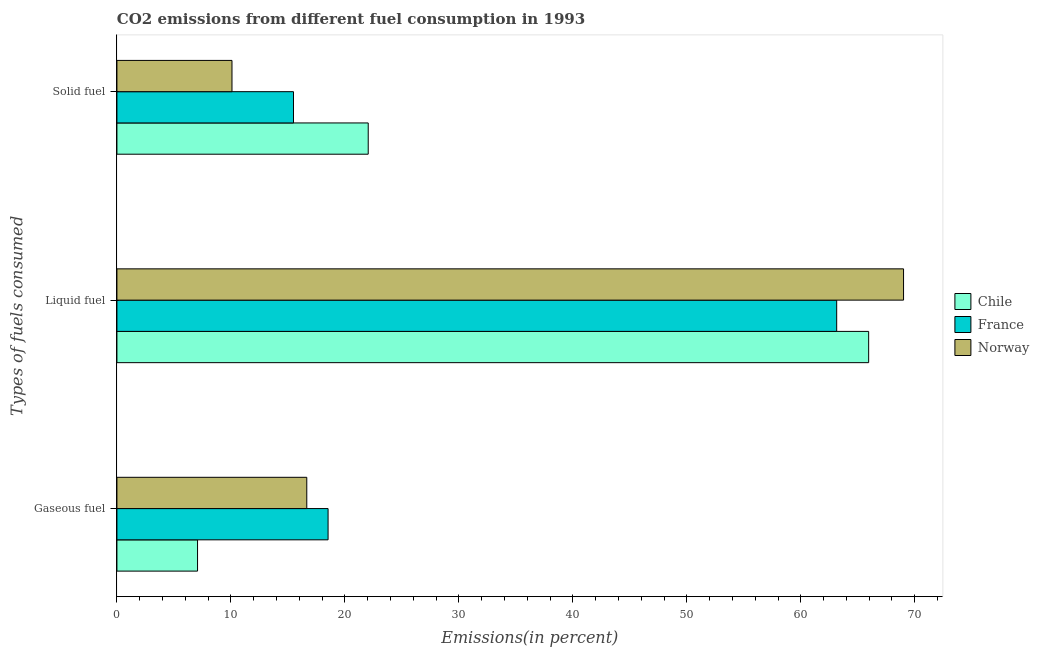Are the number of bars per tick equal to the number of legend labels?
Make the answer very short. Yes. How many bars are there on the 1st tick from the top?
Your answer should be compact. 3. How many bars are there on the 2nd tick from the bottom?
Your answer should be very brief. 3. What is the label of the 2nd group of bars from the top?
Ensure brevity in your answer.  Liquid fuel. What is the percentage of solid fuel emission in Chile?
Keep it short and to the point. 22.05. Across all countries, what is the maximum percentage of gaseous fuel emission?
Your response must be concise. 18.53. Across all countries, what is the minimum percentage of solid fuel emission?
Offer a terse response. 10.1. In which country was the percentage of solid fuel emission minimum?
Provide a succinct answer. Norway. What is the total percentage of solid fuel emission in the graph?
Your answer should be very brief. 47.63. What is the difference between the percentage of liquid fuel emission in Norway and that in Chile?
Provide a succinct answer. 3.06. What is the difference between the percentage of gaseous fuel emission in France and the percentage of solid fuel emission in Chile?
Your answer should be very brief. -3.52. What is the average percentage of liquid fuel emission per country?
Your answer should be compact. 66.04. What is the difference between the percentage of liquid fuel emission and percentage of gaseous fuel emission in France?
Ensure brevity in your answer.  44.62. What is the ratio of the percentage of liquid fuel emission in France to that in Norway?
Keep it short and to the point. 0.92. What is the difference between the highest and the second highest percentage of liquid fuel emission?
Offer a terse response. 3.06. What is the difference between the highest and the lowest percentage of gaseous fuel emission?
Your answer should be compact. 11.45. In how many countries, is the percentage of solid fuel emission greater than the average percentage of solid fuel emission taken over all countries?
Provide a short and direct response. 1. What does the 3rd bar from the top in Solid fuel represents?
Make the answer very short. Chile. How many bars are there?
Your answer should be very brief. 9. Does the graph contain any zero values?
Keep it short and to the point. No. Where does the legend appear in the graph?
Your answer should be very brief. Center right. How many legend labels are there?
Offer a very short reply. 3. What is the title of the graph?
Ensure brevity in your answer.  CO2 emissions from different fuel consumption in 1993. Does "Macao" appear as one of the legend labels in the graph?
Give a very brief answer. No. What is the label or title of the X-axis?
Your response must be concise. Emissions(in percent). What is the label or title of the Y-axis?
Your answer should be very brief. Types of fuels consumed. What is the Emissions(in percent) of Chile in Gaseous fuel?
Your response must be concise. 7.07. What is the Emissions(in percent) of France in Gaseous fuel?
Provide a short and direct response. 18.53. What is the Emissions(in percent) of Norway in Gaseous fuel?
Ensure brevity in your answer.  16.66. What is the Emissions(in percent) of Chile in Liquid fuel?
Keep it short and to the point. 65.95. What is the Emissions(in percent) in France in Liquid fuel?
Ensure brevity in your answer.  63.15. What is the Emissions(in percent) in Norway in Liquid fuel?
Offer a terse response. 69.01. What is the Emissions(in percent) in Chile in Solid fuel?
Ensure brevity in your answer.  22.05. What is the Emissions(in percent) in France in Solid fuel?
Provide a short and direct response. 15.49. What is the Emissions(in percent) in Norway in Solid fuel?
Provide a succinct answer. 10.1. Across all Types of fuels consumed, what is the maximum Emissions(in percent) in Chile?
Give a very brief answer. 65.95. Across all Types of fuels consumed, what is the maximum Emissions(in percent) in France?
Provide a short and direct response. 63.15. Across all Types of fuels consumed, what is the maximum Emissions(in percent) of Norway?
Give a very brief answer. 69.01. Across all Types of fuels consumed, what is the minimum Emissions(in percent) of Chile?
Offer a very short reply. 7.07. Across all Types of fuels consumed, what is the minimum Emissions(in percent) of France?
Make the answer very short. 15.49. Across all Types of fuels consumed, what is the minimum Emissions(in percent) of Norway?
Offer a terse response. 10.1. What is the total Emissions(in percent) of Chile in the graph?
Offer a terse response. 95.08. What is the total Emissions(in percent) of France in the graph?
Ensure brevity in your answer.  97.17. What is the total Emissions(in percent) of Norway in the graph?
Give a very brief answer. 95.77. What is the difference between the Emissions(in percent) of Chile in Gaseous fuel and that in Liquid fuel?
Provide a succinct answer. -58.88. What is the difference between the Emissions(in percent) of France in Gaseous fuel and that in Liquid fuel?
Provide a short and direct response. -44.62. What is the difference between the Emissions(in percent) of Norway in Gaseous fuel and that in Liquid fuel?
Your answer should be compact. -52.36. What is the difference between the Emissions(in percent) in Chile in Gaseous fuel and that in Solid fuel?
Give a very brief answer. -14.97. What is the difference between the Emissions(in percent) in France in Gaseous fuel and that in Solid fuel?
Provide a short and direct response. 3.03. What is the difference between the Emissions(in percent) of Norway in Gaseous fuel and that in Solid fuel?
Your answer should be compact. 6.56. What is the difference between the Emissions(in percent) of Chile in Liquid fuel and that in Solid fuel?
Your answer should be compact. 43.91. What is the difference between the Emissions(in percent) in France in Liquid fuel and that in Solid fuel?
Offer a terse response. 47.66. What is the difference between the Emissions(in percent) of Norway in Liquid fuel and that in Solid fuel?
Ensure brevity in your answer.  58.92. What is the difference between the Emissions(in percent) in Chile in Gaseous fuel and the Emissions(in percent) in France in Liquid fuel?
Provide a short and direct response. -56.07. What is the difference between the Emissions(in percent) in Chile in Gaseous fuel and the Emissions(in percent) in Norway in Liquid fuel?
Give a very brief answer. -61.94. What is the difference between the Emissions(in percent) of France in Gaseous fuel and the Emissions(in percent) of Norway in Liquid fuel?
Your answer should be compact. -50.49. What is the difference between the Emissions(in percent) of Chile in Gaseous fuel and the Emissions(in percent) of France in Solid fuel?
Make the answer very short. -8.42. What is the difference between the Emissions(in percent) of Chile in Gaseous fuel and the Emissions(in percent) of Norway in Solid fuel?
Your answer should be compact. -3.02. What is the difference between the Emissions(in percent) in France in Gaseous fuel and the Emissions(in percent) in Norway in Solid fuel?
Offer a very short reply. 8.43. What is the difference between the Emissions(in percent) of Chile in Liquid fuel and the Emissions(in percent) of France in Solid fuel?
Provide a succinct answer. 50.46. What is the difference between the Emissions(in percent) of Chile in Liquid fuel and the Emissions(in percent) of Norway in Solid fuel?
Offer a very short reply. 55.86. What is the difference between the Emissions(in percent) in France in Liquid fuel and the Emissions(in percent) in Norway in Solid fuel?
Offer a very short reply. 53.05. What is the average Emissions(in percent) in Chile per Types of fuels consumed?
Keep it short and to the point. 31.69. What is the average Emissions(in percent) of France per Types of fuels consumed?
Offer a very short reply. 32.39. What is the average Emissions(in percent) of Norway per Types of fuels consumed?
Keep it short and to the point. 31.92. What is the difference between the Emissions(in percent) of Chile and Emissions(in percent) of France in Gaseous fuel?
Provide a short and direct response. -11.45. What is the difference between the Emissions(in percent) in Chile and Emissions(in percent) in Norway in Gaseous fuel?
Your response must be concise. -9.58. What is the difference between the Emissions(in percent) of France and Emissions(in percent) of Norway in Gaseous fuel?
Your answer should be very brief. 1.87. What is the difference between the Emissions(in percent) of Chile and Emissions(in percent) of France in Liquid fuel?
Make the answer very short. 2.8. What is the difference between the Emissions(in percent) of Chile and Emissions(in percent) of Norway in Liquid fuel?
Offer a terse response. -3.06. What is the difference between the Emissions(in percent) of France and Emissions(in percent) of Norway in Liquid fuel?
Your answer should be very brief. -5.87. What is the difference between the Emissions(in percent) in Chile and Emissions(in percent) in France in Solid fuel?
Give a very brief answer. 6.56. What is the difference between the Emissions(in percent) of Chile and Emissions(in percent) of Norway in Solid fuel?
Your response must be concise. 11.95. What is the difference between the Emissions(in percent) in France and Emissions(in percent) in Norway in Solid fuel?
Your answer should be very brief. 5.4. What is the ratio of the Emissions(in percent) in Chile in Gaseous fuel to that in Liquid fuel?
Provide a succinct answer. 0.11. What is the ratio of the Emissions(in percent) in France in Gaseous fuel to that in Liquid fuel?
Provide a short and direct response. 0.29. What is the ratio of the Emissions(in percent) in Norway in Gaseous fuel to that in Liquid fuel?
Give a very brief answer. 0.24. What is the ratio of the Emissions(in percent) in Chile in Gaseous fuel to that in Solid fuel?
Give a very brief answer. 0.32. What is the ratio of the Emissions(in percent) in France in Gaseous fuel to that in Solid fuel?
Offer a very short reply. 1.2. What is the ratio of the Emissions(in percent) in Norway in Gaseous fuel to that in Solid fuel?
Your response must be concise. 1.65. What is the ratio of the Emissions(in percent) in Chile in Liquid fuel to that in Solid fuel?
Offer a terse response. 2.99. What is the ratio of the Emissions(in percent) of France in Liquid fuel to that in Solid fuel?
Ensure brevity in your answer.  4.08. What is the ratio of the Emissions(in percent) in Norway in Liquid fuel to that in Solid fuel?
Your answer should be compact. 6.84. What is the difference between the highest and the second highest Emissions(in percent) of Chile?
Provide a short and direct response. 43.91. What is the difference between the highest and the second highest Emissions(in percent) in France?
Your response must be concise. 44.62. What is the difference between the highest and the second highest Emissions(in percent) in Norway?
Offer a very short reply. 52.36. What is the difference between the highest and the lowest Emissions(in percent) of Chile?
Your answer should be compact. 58.88. What is the difference between the highest and the lowest Emissions(in percent) in France?
Provide a short and direct response. 47.66. What is the difference between the highest and the lowest Emissions(in percent) in Norway?
Provide a succinct answer. 58.92. 